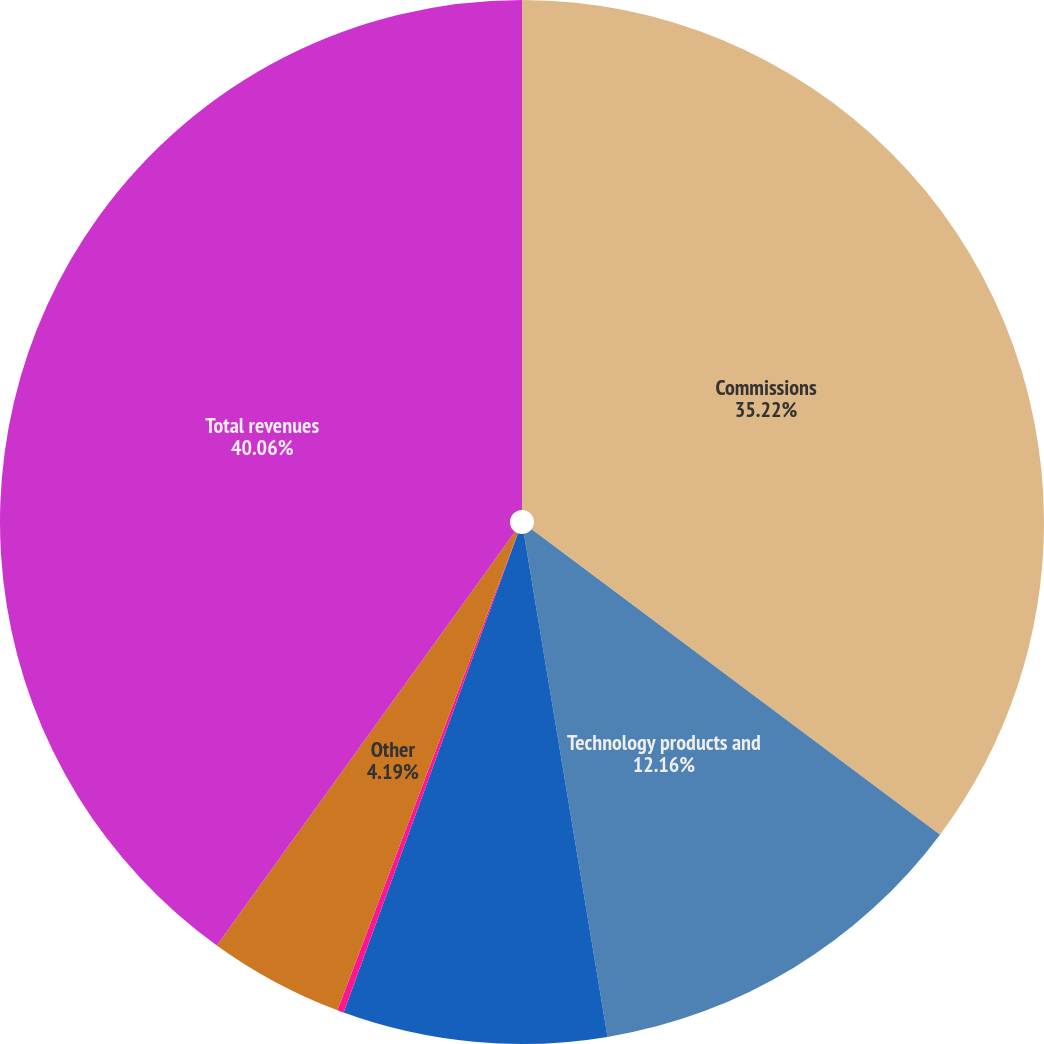Convert chart to OTSL. <chart><loc_0><loc_0><loc_500><loc_500><pie_chart><fcel>Commissions<fcel>Technology products and<fcel>Information and user access<fcel>Investment income<fcel>Other<fcel>Total revenues<nl><fcel>35.22%<fcel>12.16%<fcel>8.17%<fcel>0.2%<fcel>4.19%<fcel>40.06%<nl></chart> 